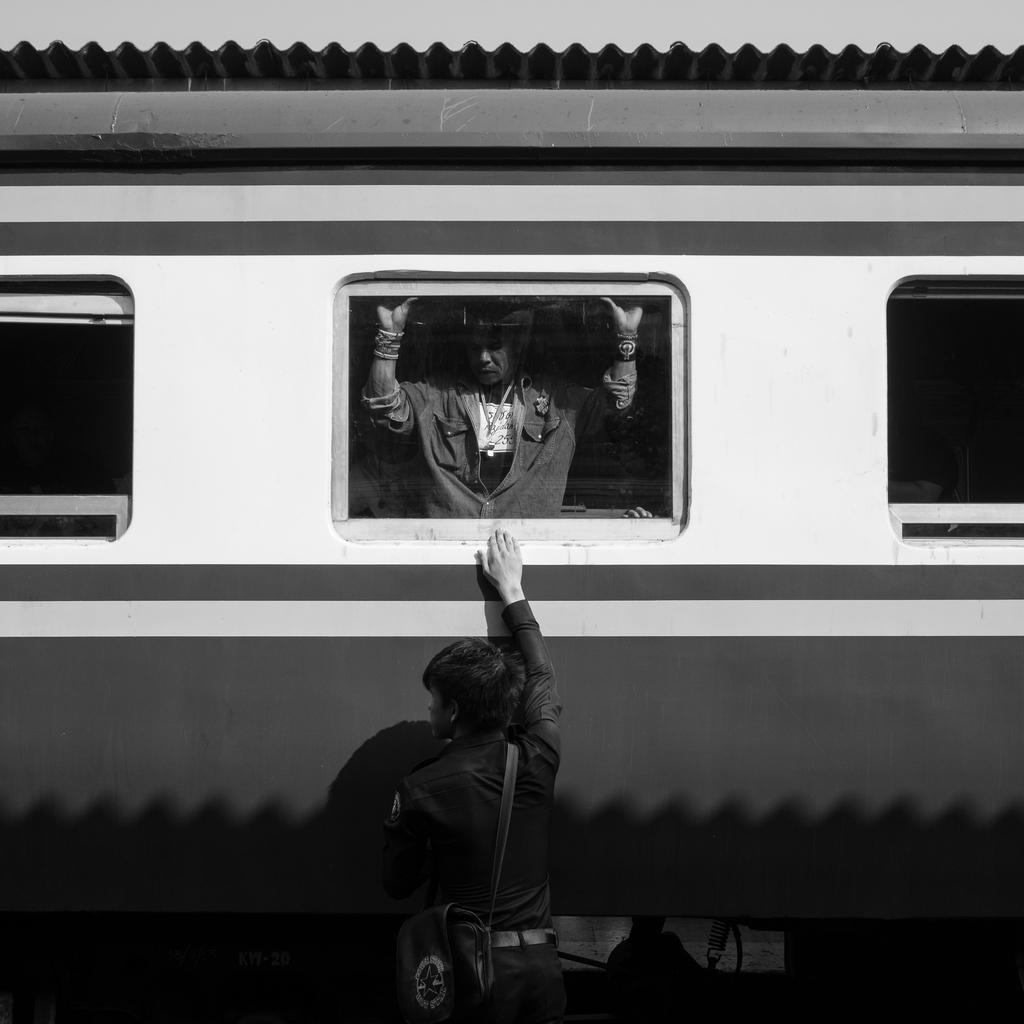What is the color scheme of the image? The image is black and white. Can you describe the people in the image? There is a person standing, and another person is standing inside a railway coach. What mode of transportation is visible in the image? A railway coach is visible in the image. What type of pets can be seen playing with a yam in the image? There are no pets or yams present in the image; it features a person standing outside and another person standing inside a railway coach. 